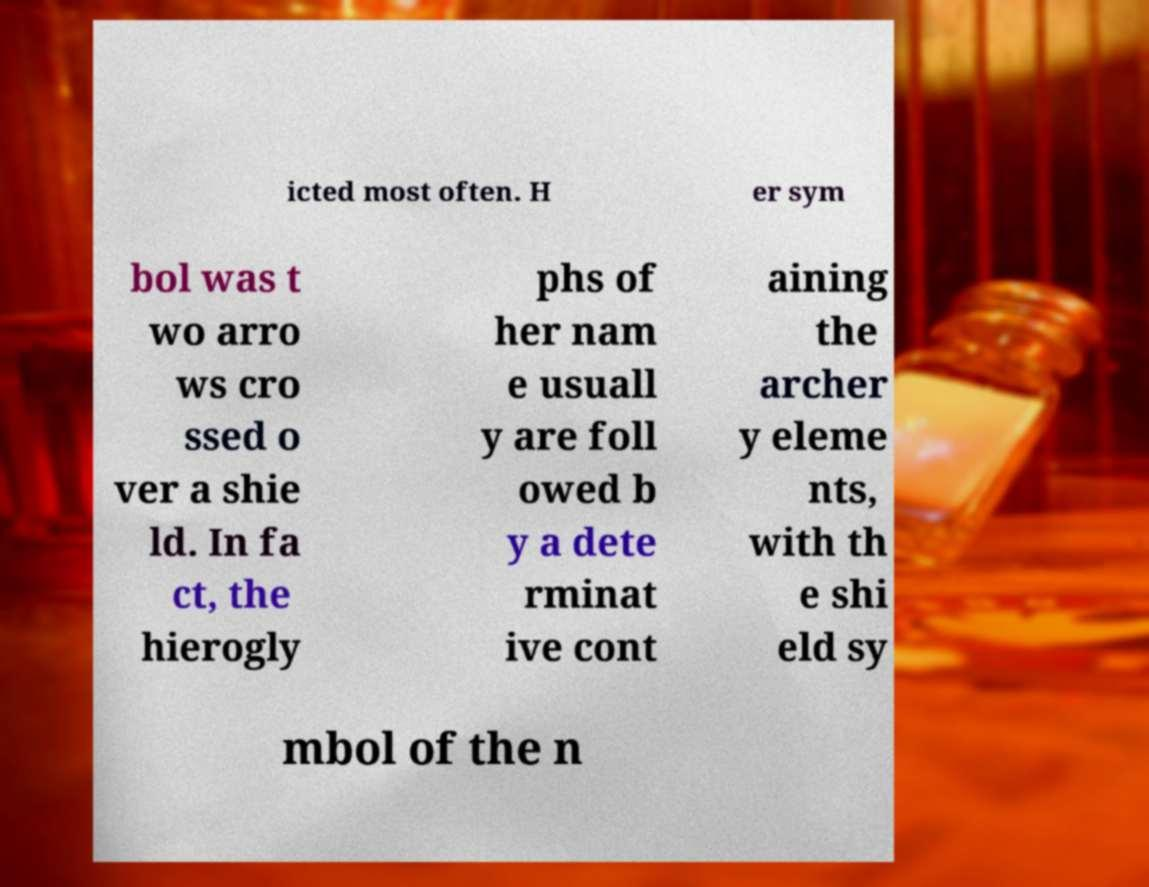Could you assist in decoding the text presented in this image and type it out clearly? icted most often. H er sym bol was t wo arro ws cro ssed o ver a shie ld. In fa ct, the hierogly phs of her nam e usuall y are foll owed b y a dete rminat ive cont aining the archer y eleme nts, with th e shi eld sy mbol of the n 